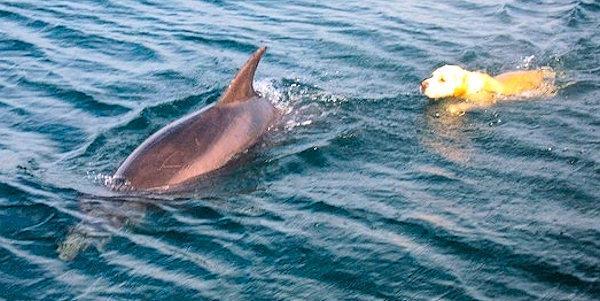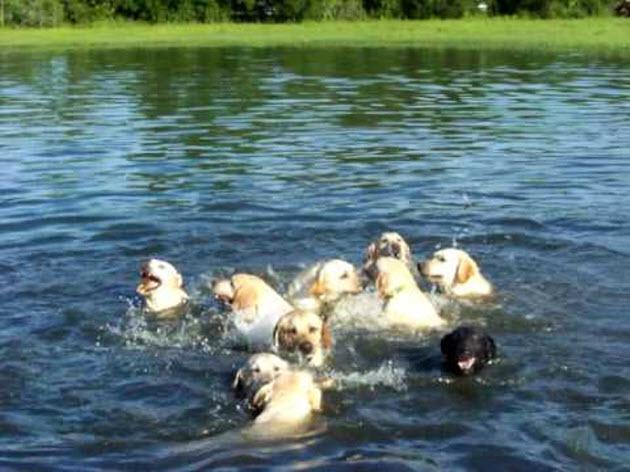The first image is the image on the left, the second image is the image on the right. Assess this claim about the two images: "An image shows dogs in a wet area and includes one black dog with at least six """"blond"""" ones.". Correct or not? Answer yes or no. Yes. The first image is the image on the left, the second image is the image on the right. Assess this claim about the two images: "There's no more than three dogs in the right image.". Correct or not? Answer yes or no. No. 